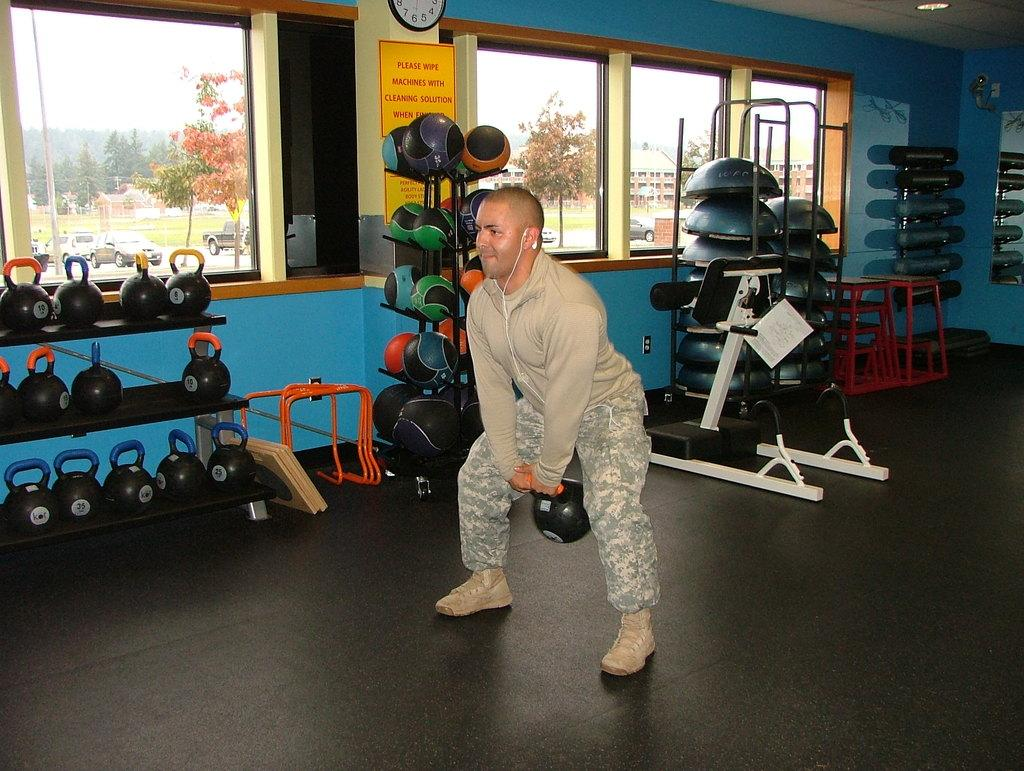Provide a one-sentence caption for the provided image. A man is lifting weights in a weight room and there is a sign in the room that says "Please wipe machines with cleaning solution when finished.". 